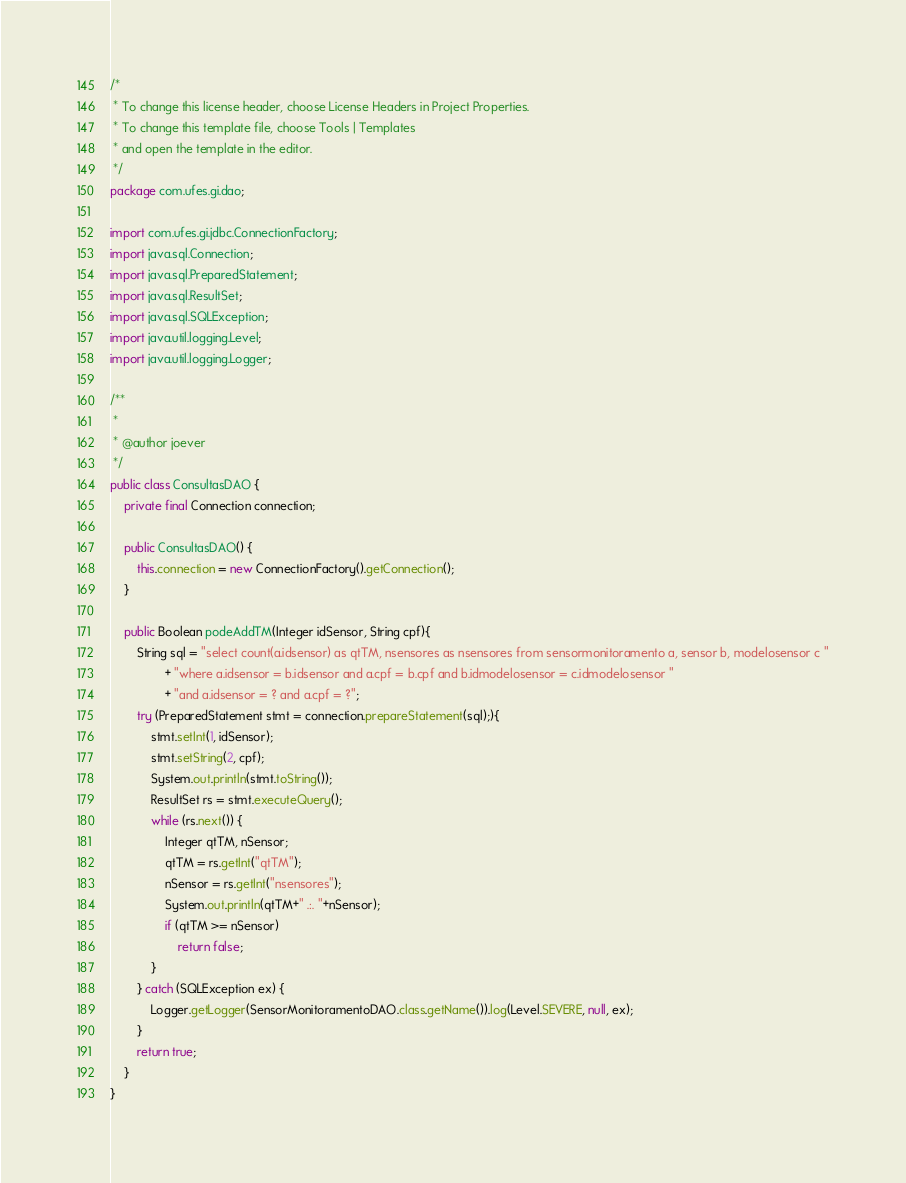Convert code to text. <code><loc_0><loc_0><loc_500><loc_500><_Java_>/*
 * To change this license header, choose License Headers in Project Properties.
 * To change this template file, choose Tools | Templates
 * and open the template in the editor.
 */
package com.ufes.gi.dao;

import com.ufes.gi.jdbc.ConnectionFactory;
import java.sql.Connection;
import java.sql.PreparedStatement;
import java.sql.ResultSet;
import java.sql.SQLException;
import java.util.logging.Level;
import java.util.logging.Logger;

/**
 *
 * @author joever
 */
public class ConsultasDAO {
    private final Connection connection;
    
    public ConsultasDAO() {
        this.connection = new ConnectionFactory().getConnection();
    }
    
    public Boolean podeAddTM(Integer idSensor, String cpf){
        String sql = "select count(a.idsensor) as qtTM, nsensores as nsensores from sensormonitoramento a, sensor b, modelosensor c "
                + "where a.idsensor = b.idsensor and a.cpf = b.cpf and b.idmodelosensor = c.idmodelosensor "
                + "and a.idsensor = ? and a.cpf = ?";
        try (PreparedStatement stmt = connection.prepareStatement(sql);){
            stmt.setInt(1, idSensor);
            stmt.setString(2, cpf);
            System.out.println(stmt.toString());
            ResultSet rs = stmt.executeQuery();
            while (rs.next()) {
                Integer qtTM, nSensor;
                qtTM = rs.getInt("qtTM");
                nSensor = rs.getInt("nsensores");
                System.out.println(qtTM+" .:. "+nSensor);
                if (qtTM >= nSensor)
                    return false;
            }
        } catch (SQLException ex) {
            Logger.getLogger(SensorMonitoramentoDAO.class.getName()).log(Level.SEVERE, null, ex);
        }
        return true;
    }
}
</code> 